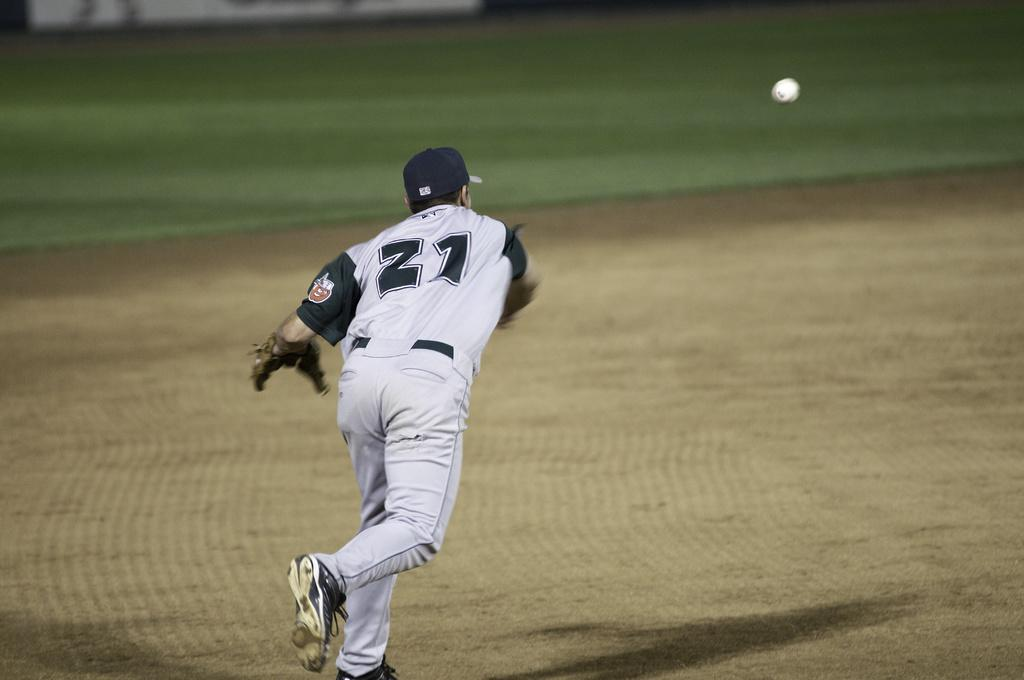Provide a one-sentence caption for the provided image. Number 21 wearing a white jersey, throws a baseball across the field. 